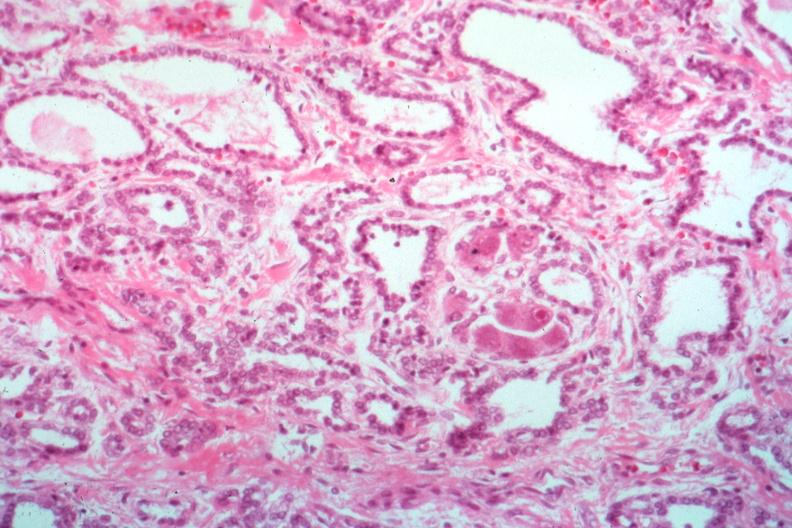what is present?
Answer the question using a single word or phrase. Thyroid 